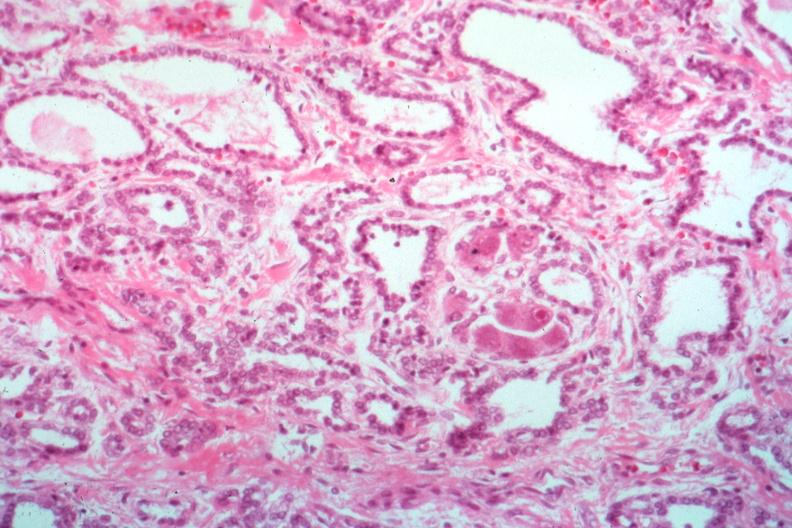what is present?
Answer the question using a single word or phrase. Thyroid 